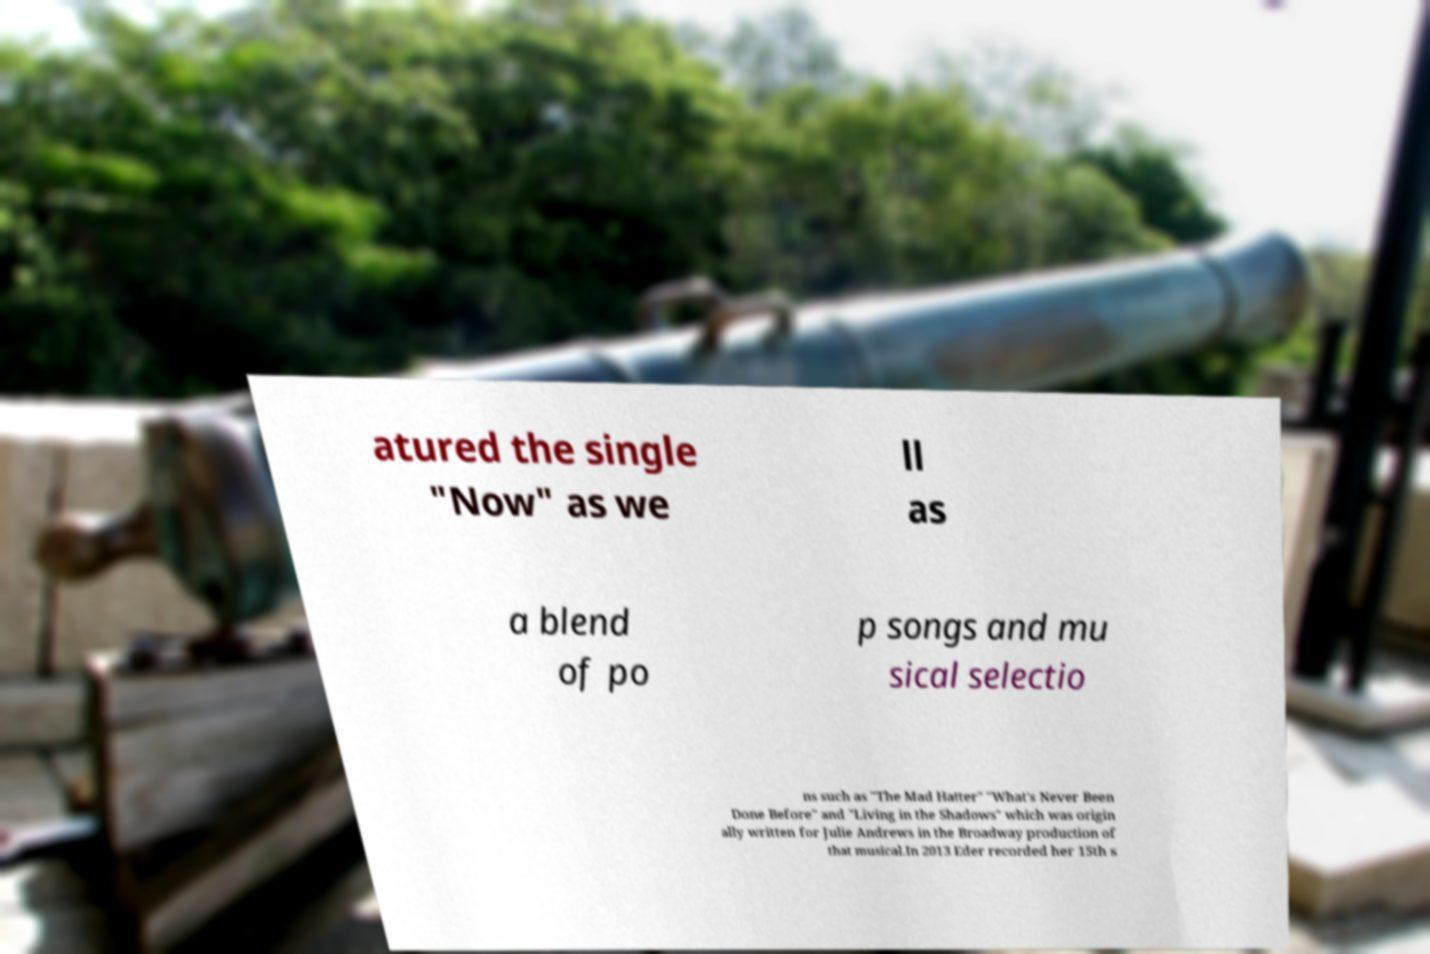Can you accurately transcribe the text from the provided image for me? atured the single "Now" as we ll as a blend of po p songs and mu sical selectio ns such as "The Mad Hatter" "What's Never Been Done Before" and "Living in the Shadows" which was origin ally written for Julie Andrews in the Broadway production of that musical.In 2013 Eder recorded her 15th s 